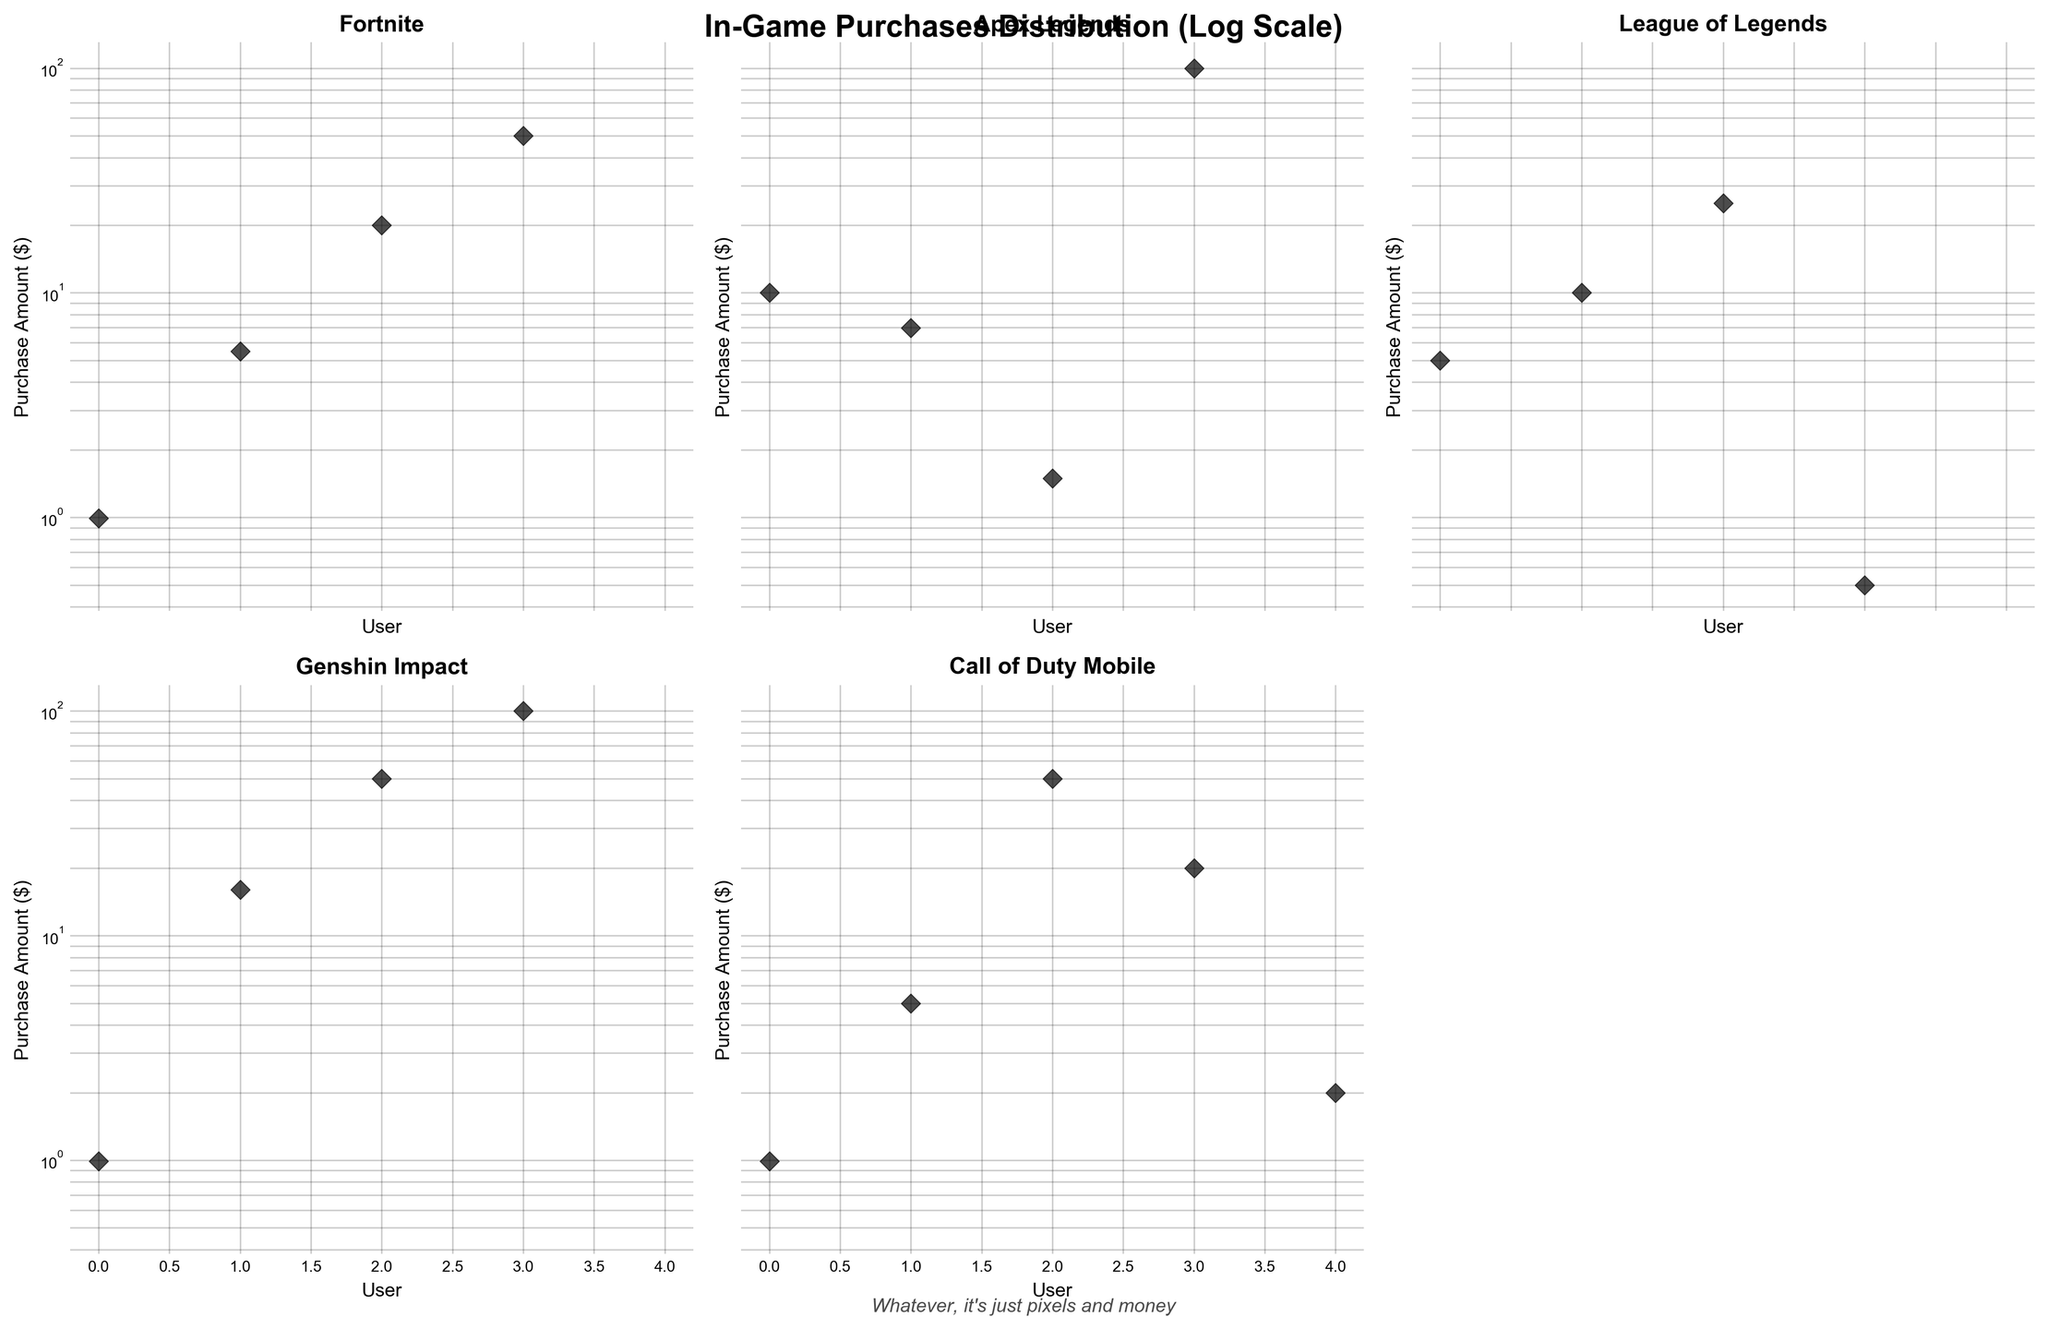What is the title of the figure? The title of the figure is displayed at the top center of the plot. It reads, "In-Game Purchases Distribution (Log Scale)" in a bold font.
Answer: In-Game Purchases Distribution (Log Scale) Which game has the highest purchase logged in the figure? By examining the distribution across all subplots, the highest purchase point is seen in "Genshin Impact," where there is a purchase of $100.
Answer: Genshin Impact Which subplot is unused in the figure? The figure is composed of 6 subplots, but only 5 of them have data. The last subplot on the bottom-right corner is unused and appears blank.
Answer: The last subplot on the bottom-right corner How many users in total are shown making purchases in "Fortnite"? Each data point represents a user's in-game purchase. The "Fortnite" subplot has 4 data points (excluding the zero purchases), indicating 4 users made purchases.
Answer: 4 users Which game has the lowest minimum purchase amount logged? By inspecting all subplots, "League of Legends" shows the lowest minimum purchase of $0.50.
Answer: League of Legends Are the axes shared among the subplots? The axes are indeed shared among all subplots, as indicated by the uniformity in the tick marks and range. This is evident since all subplots have the same axis designations.
Answer: Yes, the axes are shared Compare the number of users who made purchases for "Apex Legends" and "Call of Duty Mobile". Which game has more users making purchases? Count the data points in each subplot: "Apex Legends" has 4 data points, while "Call of Duty Mobile" has 5. Therefore, "Call of Duty Mobile" has more users making purchases.
Answer: Call of Duty Mobile What's the price range for purchases in "League of Legends"? To determine the range, look for the lowest and highest purchase amounts in "League of Legends." The purchases range from $0.50 to $25.00.
Answer: $0.50 to $25.00 Which game shows the most varied purchase amounts? By observing the spread of data points within each subplot, it is evident that "Genshin Impact" shows the most variation, ranging from $0.99 to $100.00.
Answer: Genshin Impact What does the figure's subtitle express? The figure includes a subtitle at the bottom center that reads, "Whatever, it's just pixels and money," in an italic and casual tone, adding a touch of humor.
Answer: Whatever, it's just pixels and money 